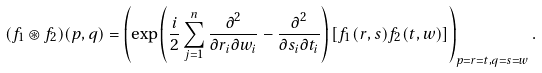<formula> <loc_0><loc_0><loc_500><loc_500>( f _ { 1 } \circledast f _ { 2 } ) ( p , q ) = \left ( \exp \left ( \frac { i } { 2 } \sum _ { j = 1 } ^ { n } \frac { \partial ^ { 2 } } { \partial r _ { i } \partial w _ { i } } - \frac { \partial ^ { 2 } } { \partial s _ { i } \partial t _ { i } } \right ) \left [ f _ { 1 } ( r , s ) f _ { 2 } ( t , w ) \right ] \right ) _ { p = r = t , q = s = w } .</formula> 